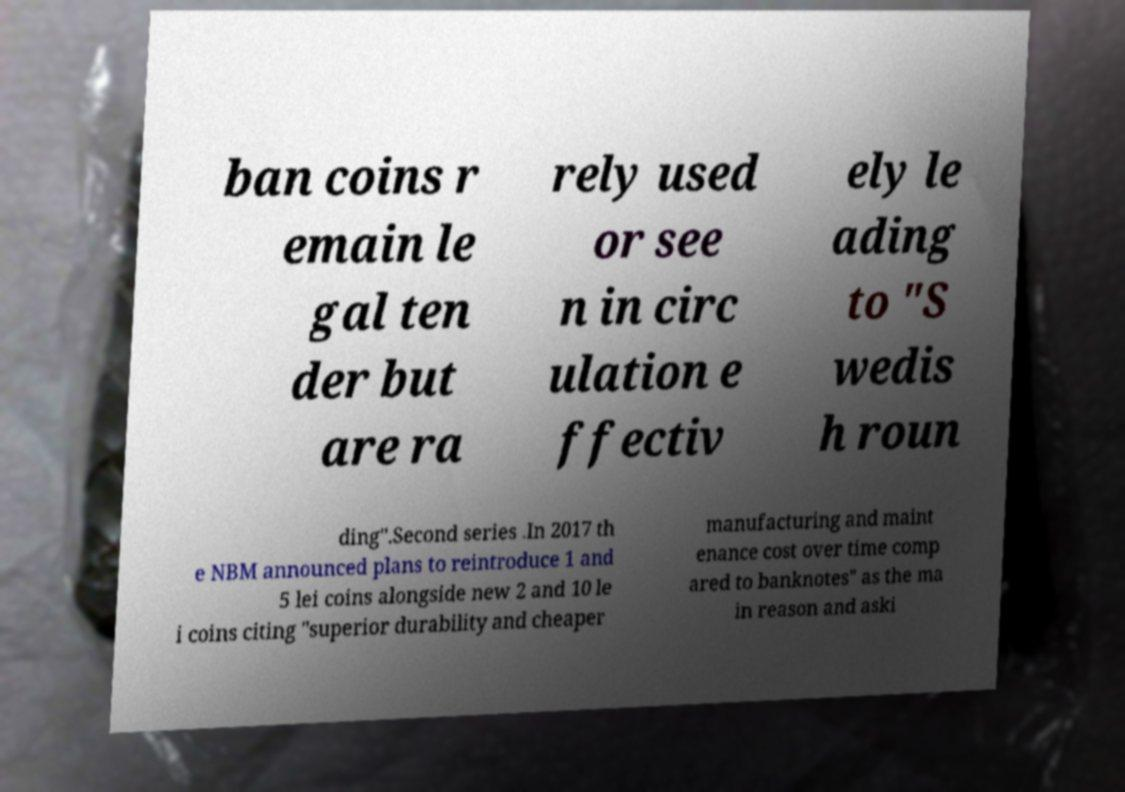I need the written content from this picture converted into text. Can you do that? ban coins r emain le gal ten der but are ra rely used or see n in circ ulation e ffectiv ely le ading to "S wedis h roun ding".Second series .In 2017 th e NBM announced plans to reintroduce 1 and 5 lei coins alongside new 2 and 10 le i coins citing "superior durability and cheaper manufacturing and maint enance cost over time comp ared to banknotes" as the ma in reason and aski 